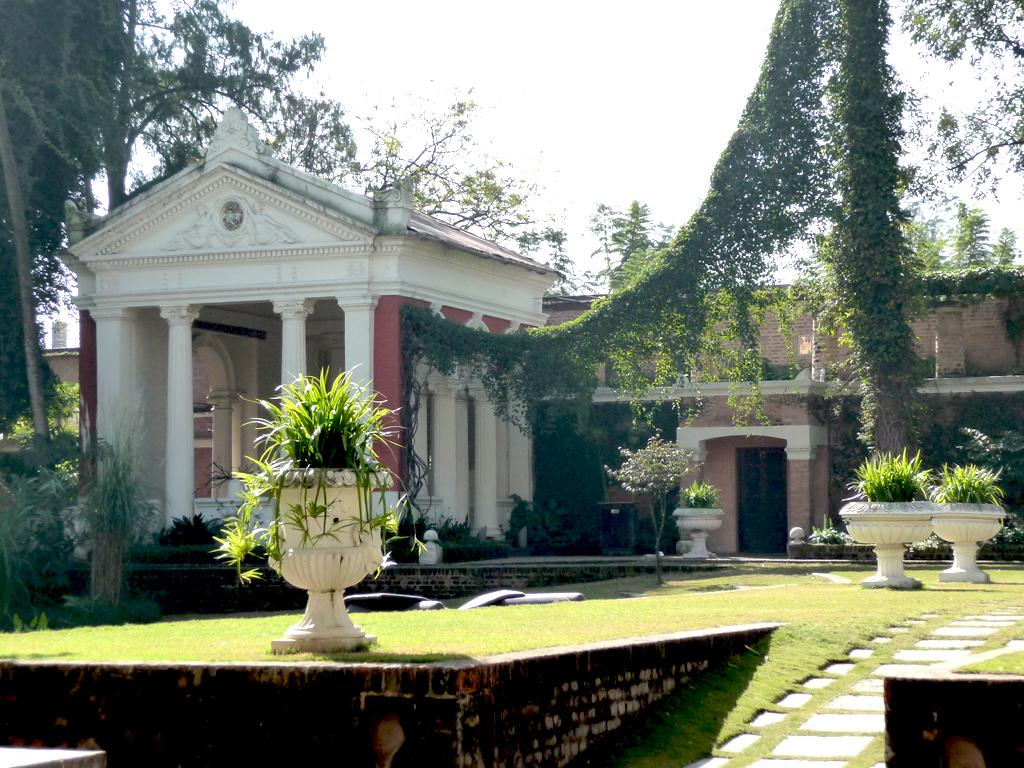What type of terrain is visible in the image? There is an open grass ground in the image. What can be found on the grass ground? There are plants on the grass ground. What color are the things visible in the image? There are white-colored things in the image. What can be seen in the distance in the image? There is a building and trees in the background of the image, and the sky is visible as well. How many friends are sitting on the grass ground in the image? There are no friends or people visible in the image; it only shows an open grass ground with plants and white-colored things. 